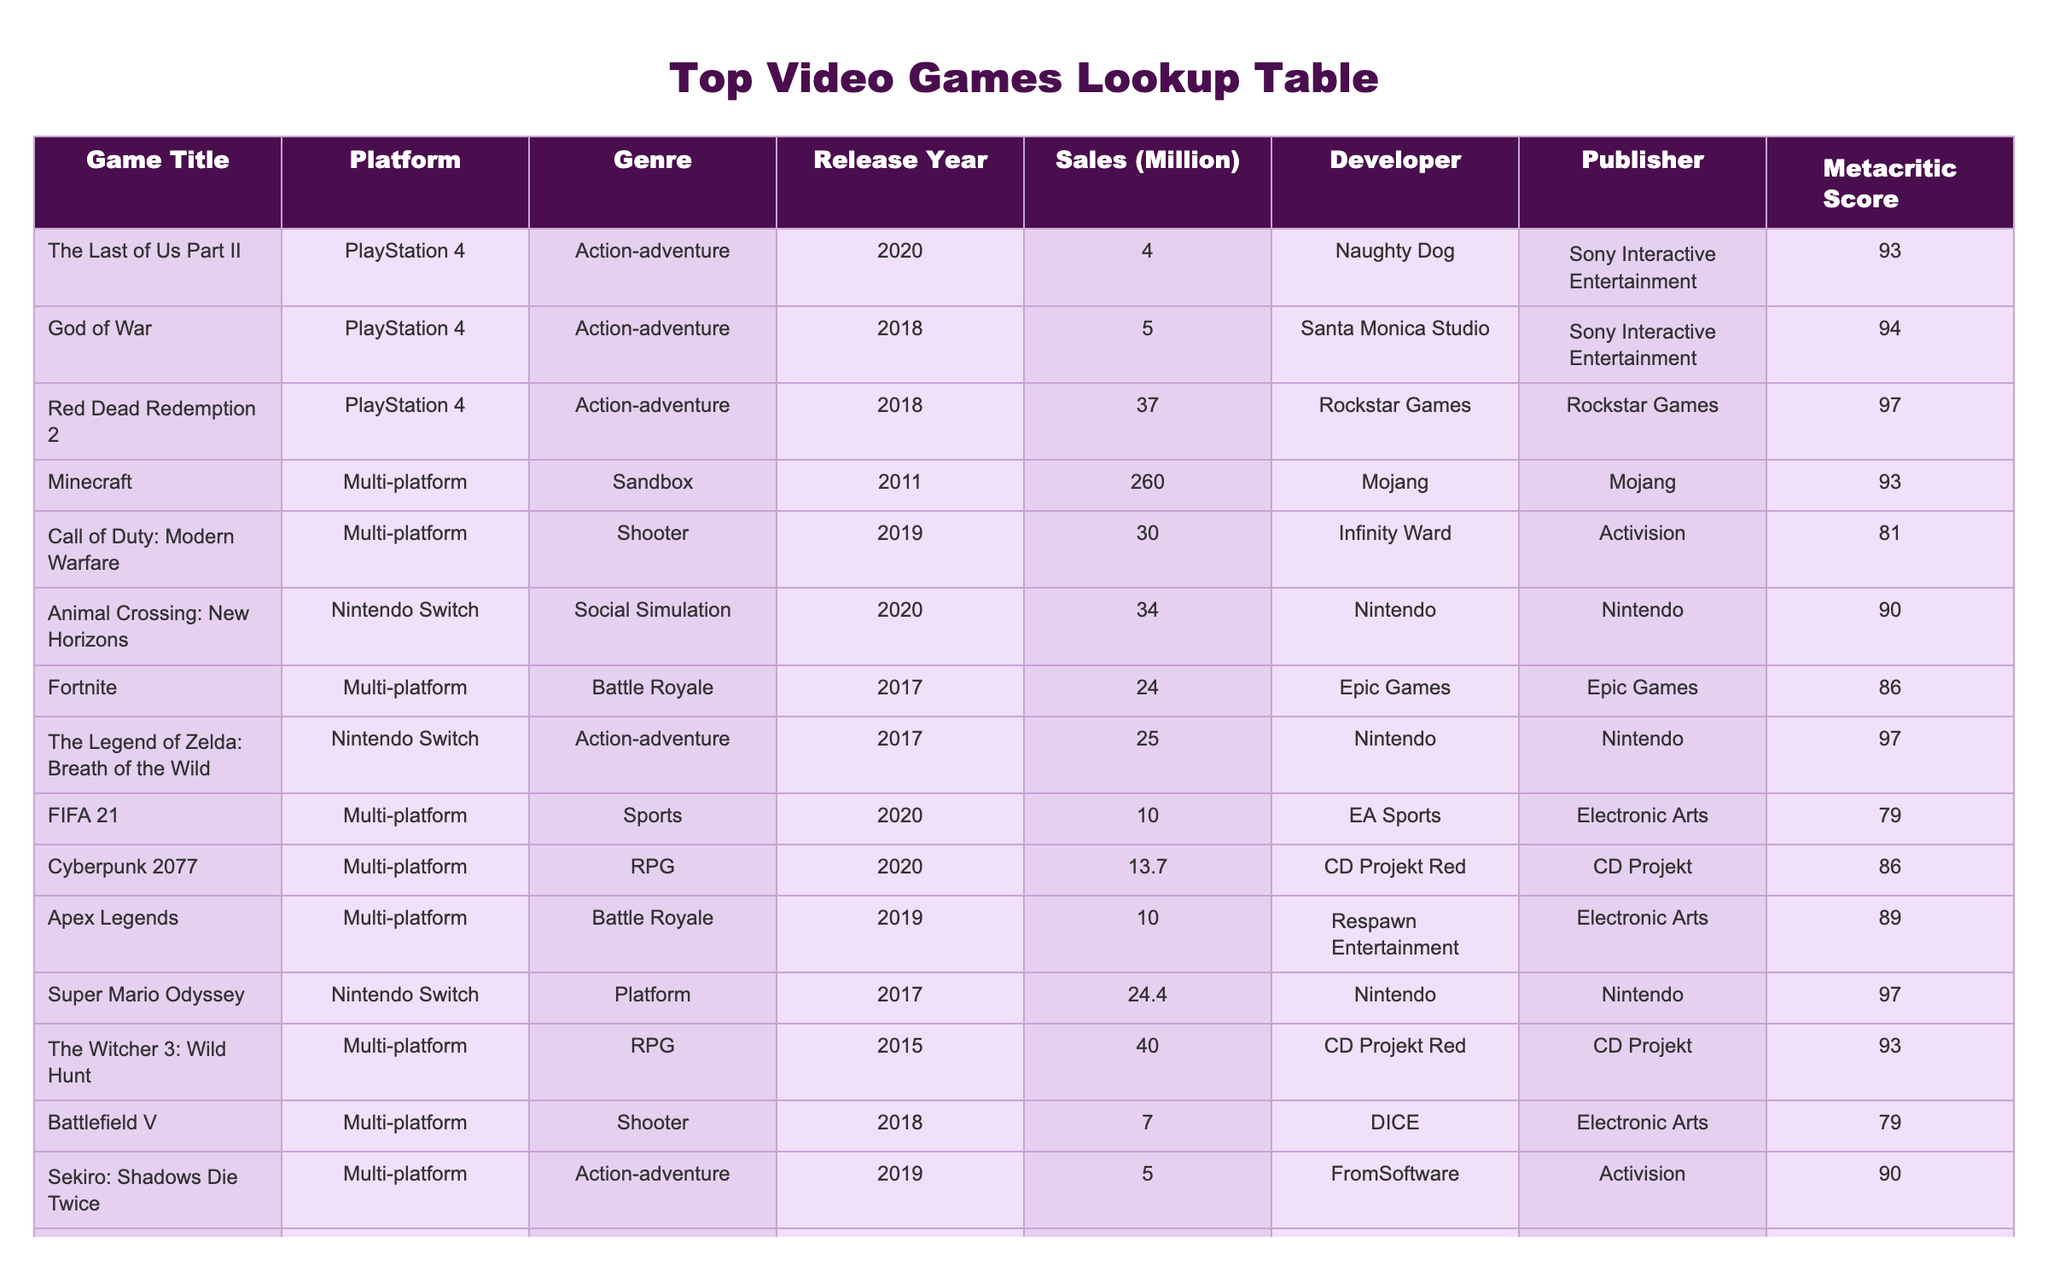What is the total sales for games released in 2020? The relevant games released in 2020 are: The Last of Us Part II (4.0 million), Animal Crossing: New Horizons (34.0 million), FIFA 21 (10.0 million), Cyberpunk 2077 (13.7 million), Ghost of Tsushima (6.5 million), and Assassin's Creed Valhalla (9.0 million). Adding these sales values together gives us 4.0 + 34.0 + 10.0 + 13.7 + 6.5 + 9.0 = 77.2 million.
Answer: 77.2 million Which platform has the highest sales for a single game? The game with the highest sales is Minecraft on multiple platforms, with 260.0 million in sales. This can be found directly in the table under the 'Sales (Million)' column.
Answer: Multi-platform Is the Metacritic score of Red Dead Redemption 2 greater than 90? Red Dead Redemption 2 has a Metacritic score of 97, which is indeed greater than 90. This can be verified directly from the 'Metacritic Score' column.
Answer: Yes What is the average sales of games on the Nintendo Switch? The relevant games for Nintendo Switch are: Animal Crossing: New Horizons (34.0 million), The Legend of Zelda: Breath of the Wild (25.0 million), Super Mario Odyssey (24.4 million). The total sales for these games are 34.0 + 25.0 + 24.4 = 83.4 million. There are 3 games, so the average sales is 83.4 million / 3 = 27.8 million.
Answer: 27.8 million Was there any game developed by Ubisoft Montreal released in 2020? The only game developed by Ubisoft Montreal mentioned in the table is Assassin's Creed Valhalla, which was released in 2020. This fact is confirmed by checking the 'Developer' and 'Release Year' columns.
Answer: Yes What sales figure is associated with the game Ghost of Tsushima? Ghost of Tsushima has a sales figure of 6.5 million, which can be directly referenced in the table.
Answer: 6.5 million How many games have a Metacritic score of 90 or higher? The games with scores of 90 or higher are: The Last of Us Part II (93), God of War (94), Red Dead Redemption 2 (97), The Legend of Zelda: Breath of the Wild (97), Super Mario Odyssey (97), The Witcher 3: Wild Hunt (93), and Animal Crossing: New Horizons (90). This gives a total of 7 games with a Metacritic score of 90 or higher.
Answer: 7 What is the difference in sales between the best-selling game and the lowest-selling game? The best-selling game is Minecraft (260.0 million) and the lowest-selling game is Battlefield V (7.0 million). The difference in sales is 260.0 million - 7.0 million = 253.0 million.
Answer: 253.0 million Which genre has the most games listed in the table? By reviewing the table, Action-adventure appears to have 6 entries: The Last of Us Part II, God of War, Red Dead Redemption 2, Ghost of Tsushima, and Sekiro: Shadows Die Twice. None of the other genres have more than this number, confirming that Action-adventure has the most entries listed.
Answer: Action-adventure 